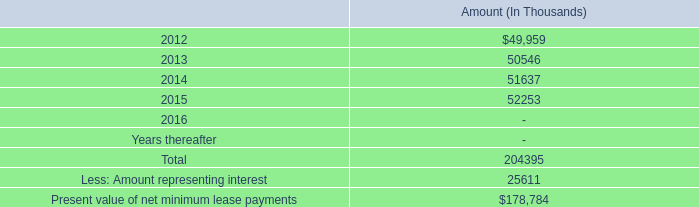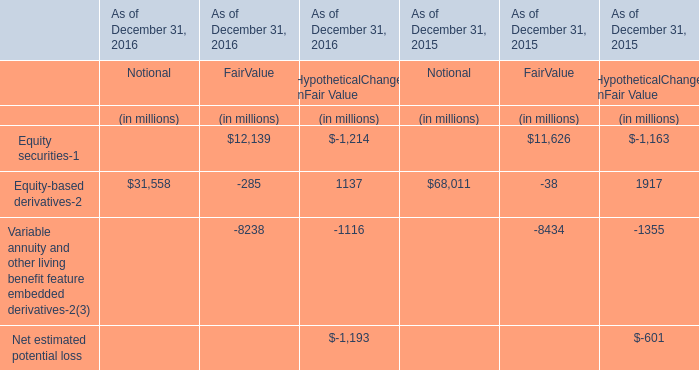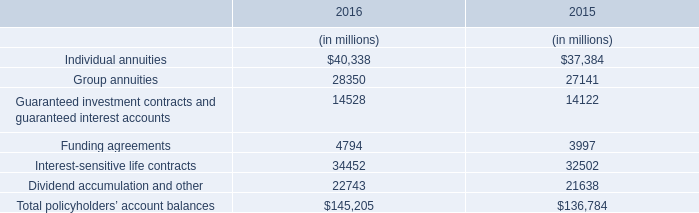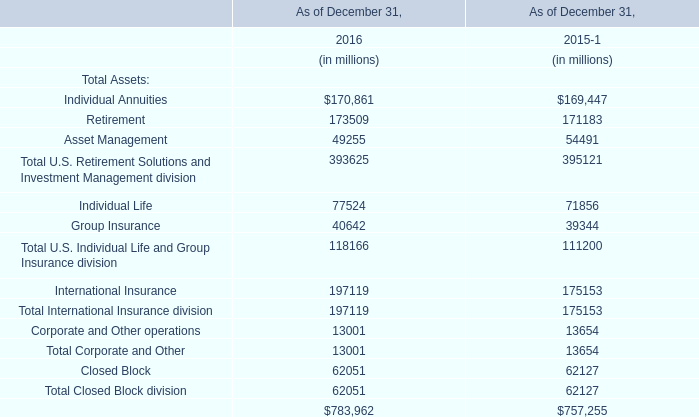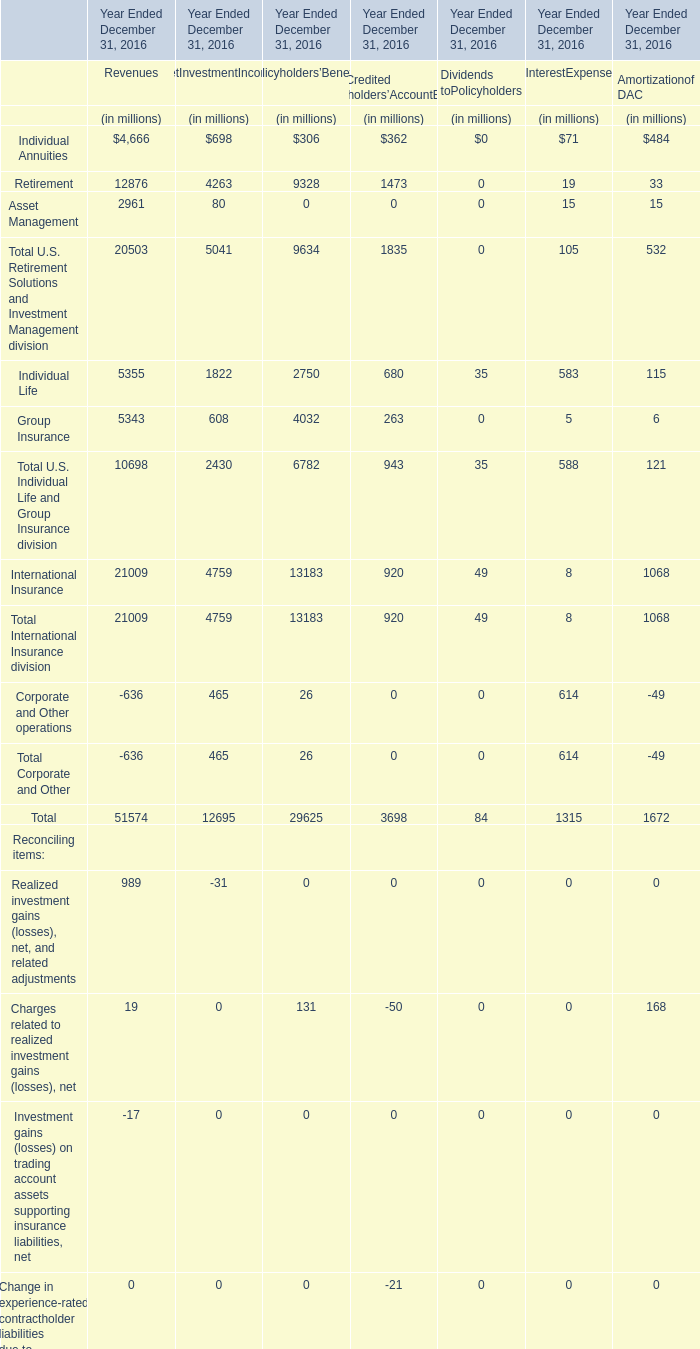What's the increasing rate of Total International Insurance division as of December 31 in 2016? 
Computations: ((197119 - 175153) / 175153)
Answer: 0.12541. 